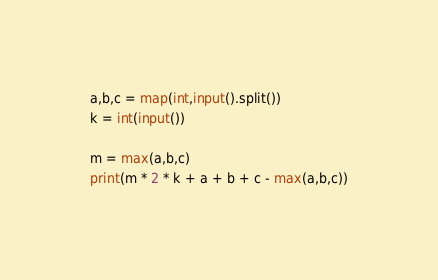Convert code to text. <code><loc_0><loc_0><loc_500><loc_500><_Python_>a,b,c = map(int,input().split())
k = int(input())

m = max(a,b,c)
print(m * 2 * k + a + b + c - max(a,b,c))</code> 